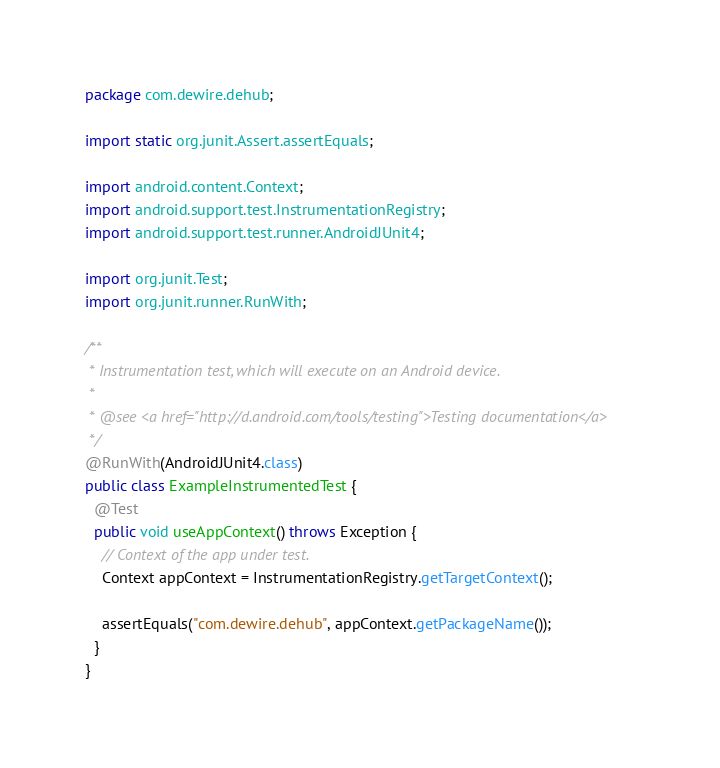Convert code to text. <code><loc_0><loc_0><loc_500><loc_500><_Java_>package com.dewire.dehub;

import static org.junit.Assert.assertEquals;

import android.content.Context;
import android.support.test.InstrumentationRegistry;
import android.support.test.runner.AndroidJUnit4;

import org.junit.Test;
import org.junit.runner.RunWith;

/**
 * Instrumentation test, which will execute on an Android device.
 *
 * @see <a href="http://d.android.com/tools/testing">Testing documentation</a>
 */
@RunWith(AndroidJUnit4.class)
public class ExampleInstrumentedTest {
  @Test
  public void useAppContext() throws Exception {
    // Context of the app under test.
    Context appContext = InstrumentationRegistry.getTargetContext();

    assertEquals("com.dewire.dehub", appContext.getPackageName());
  }
}
</code> 